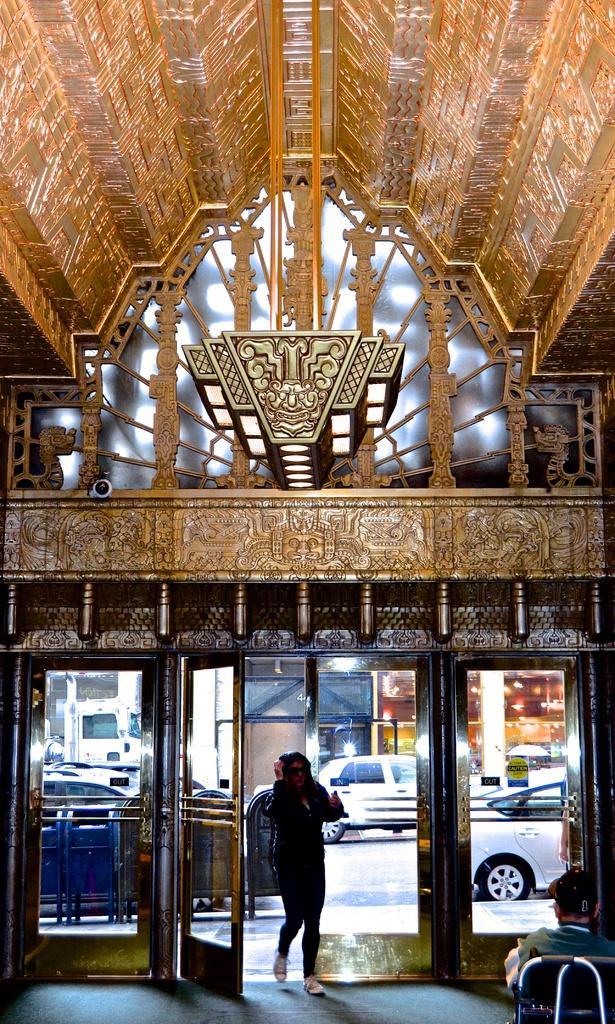Can you describe this image briefly? In this image, we can see carvings on the surfaces. Here we can see few objects. At the bottom of the image, we can see a woman is walking through the walkway. Here we can see glass doors. Through the glass, we can see vehicles, road and some objects. On the right side bottom corner, we can see a person is sitting on the chair. 